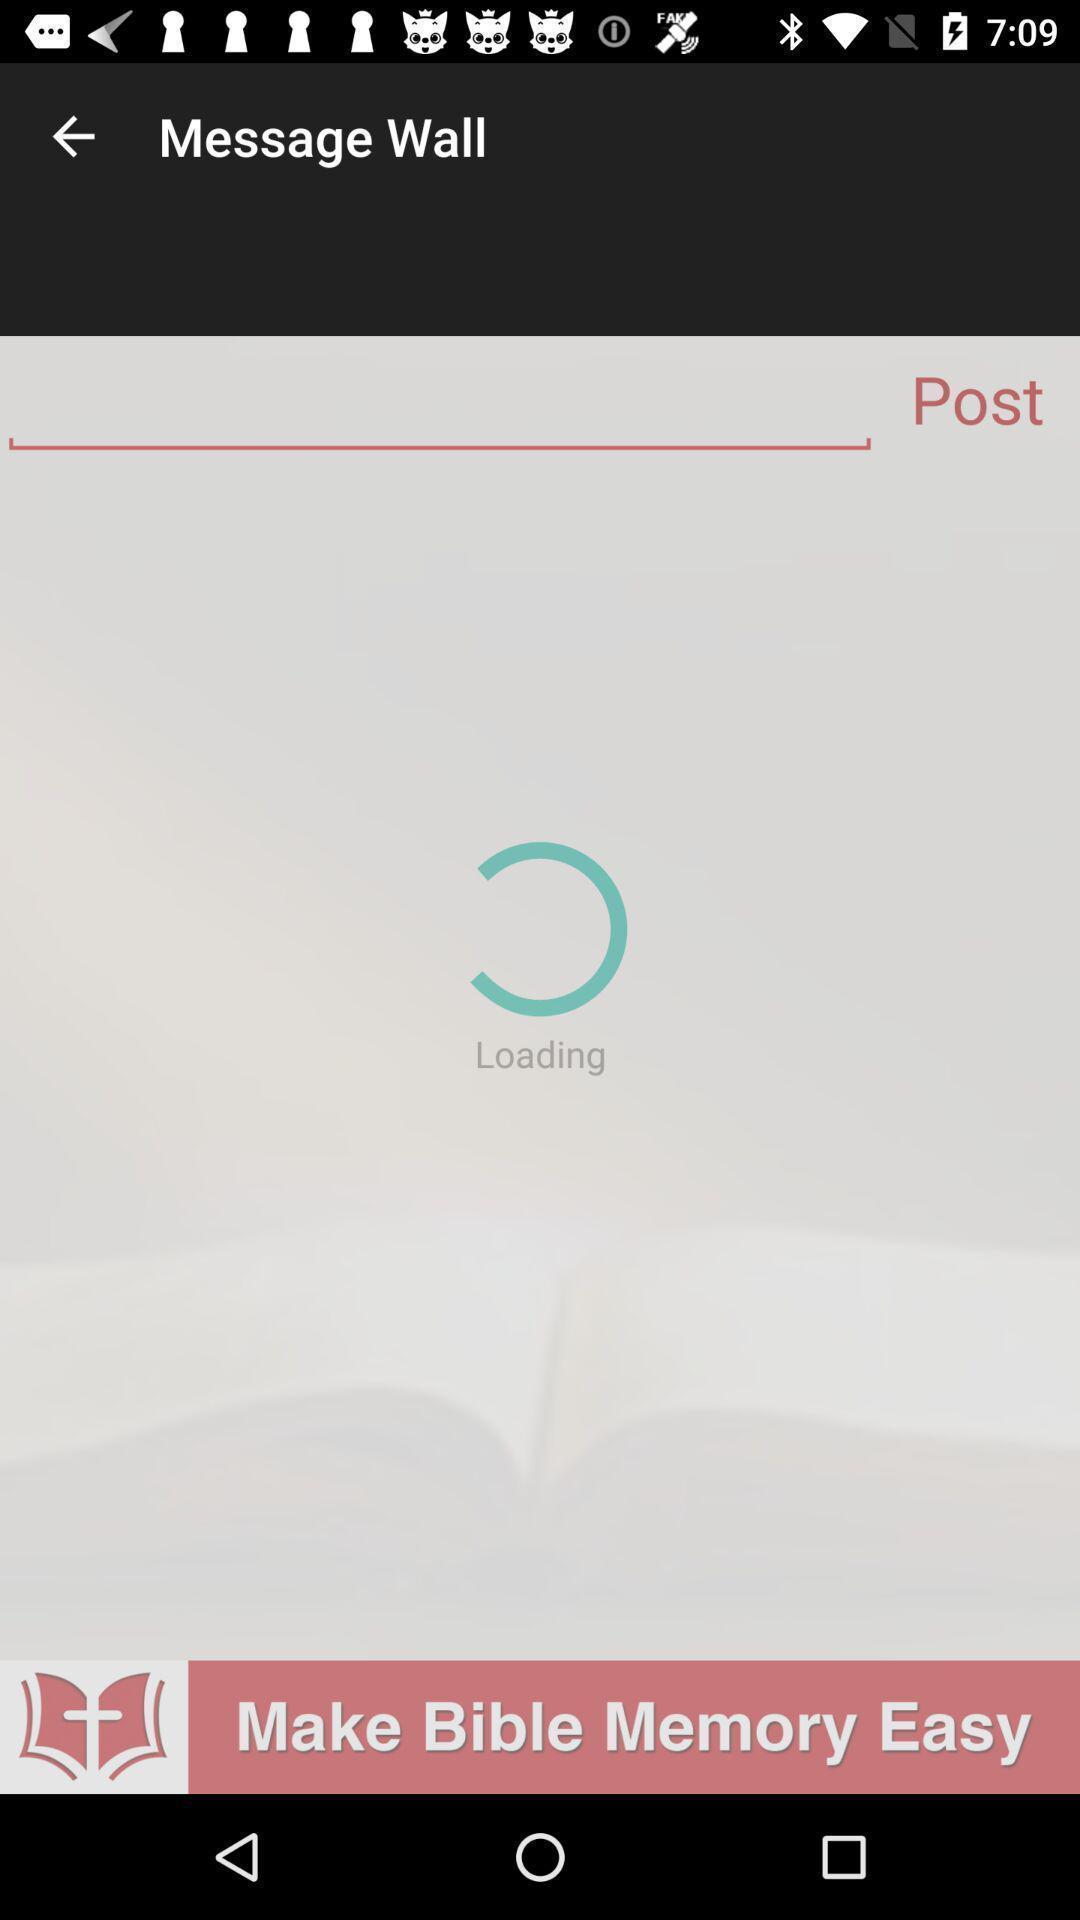Explain what's happening in this screen capture. Screen displaying a loading issue in chatting application. 